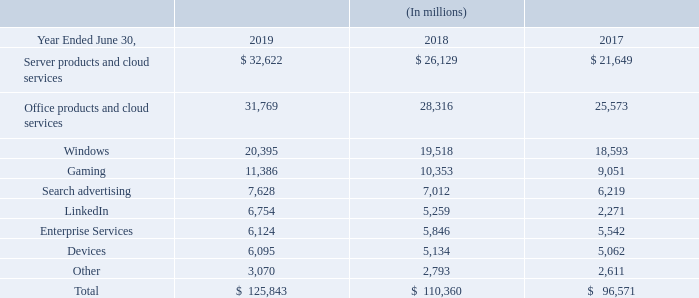Revenue from external customers, classified by significant product and service offerings, was as follows:
Our commercial cloud revenue, which includes Office 365 Commercial, Azure, the commercial portion of LinkedIn, Dynamics 365, and other commercial cloud properties, was $38.1 billion, $26.6 billion and $16.2 billion in fiscal years 2019, 2018, and 2017, respectively. These amounts are primarily included in Office products and cloud services, Server products and cloud services, and LinkedIn in the table above.
What does the company's commercial cloud revenue contain? Office 365 commercial, azure, the commercial portion of linkedin, dynamics 365, and other commercial cloud properties. How much revenue did the commercial cloud area generate in 2017? $16.2 billion. How much revenue came from LinkedIn in 2019?
Answer scale should be: million. 6,754. How many revenue items are there? Server products and cloud services## Office products and cloud services## Windows## Gaming## Search advertising## LinkedIn## Enterprise Services## Devices## Other
Answer: 9. How much of the total revenue in 2019 did not come from commercial cloud revenue?
Answer scale should be: million. 125,843 million - 38.1 billion 
Answer: 87743. Which were the bottom 2 revenue items for 2017?  21,649>25,573>18,593>9,051>6,219>5,542>5,062>2,611>2,271
Answer: linkedin, other. 